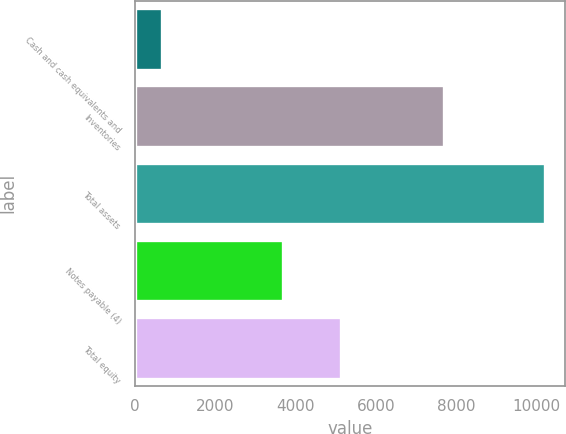Convert chart to OTSL. <chart><loc_0><loc_0><loc_500><loc_500><bar_chart><fcel>Cash and cash equivalents and<fcel>Inventories<fcel>Total assets<fcel>Notes payable (4)<fcel>Total equity<nl><fcel>661.8<fcel>7700.5<fcel>10202.5<fcel>3682.8<fcel>5119.7<nl></chart> 